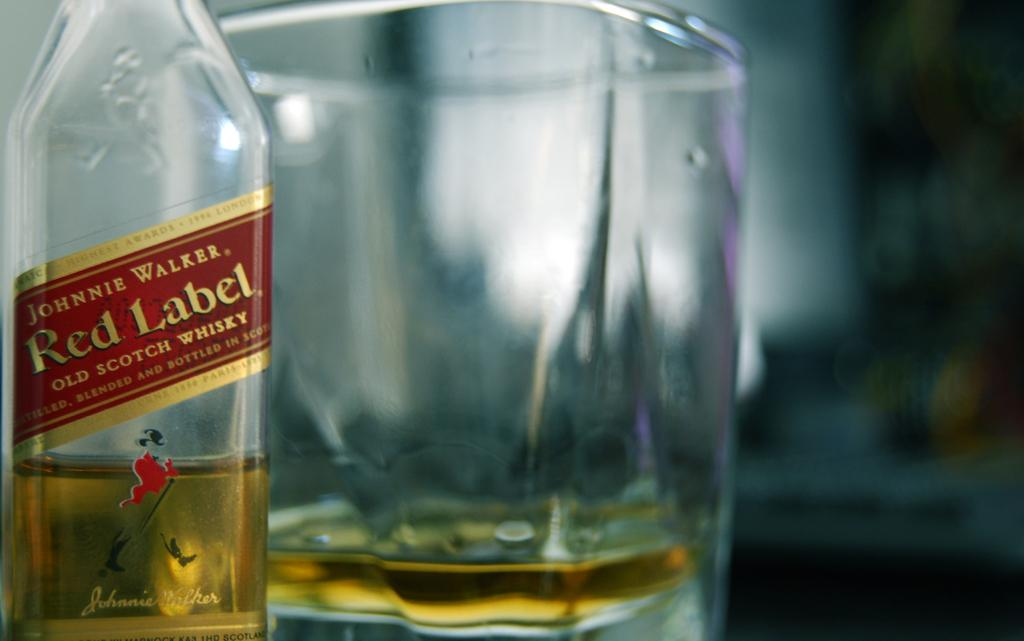<image>
Render a clear and concise summary of the photo. A glass of whiskey is served neat and is next to a bottle of Johnnie Walker Red. 